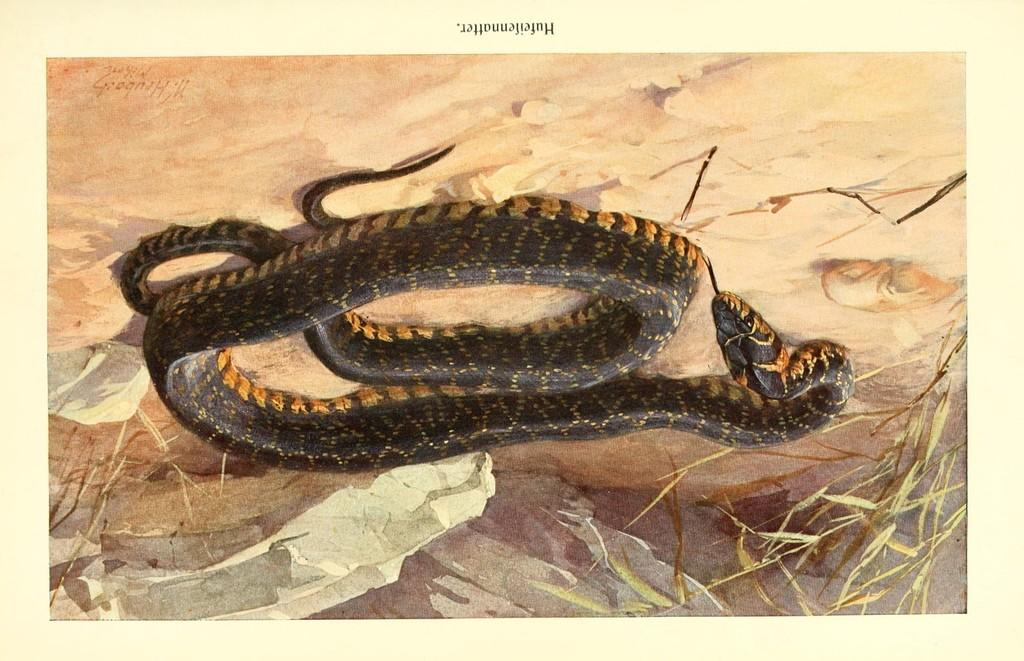What type of animal is present in the image? There is a snake in the image. What else can be seen in the image besides the snake? There is text visible in the image, as well as dry leaves. What type of suit is the snake wearing in the image? There is no suit present in the image, as the snake is an animal and does not wear clothing. 